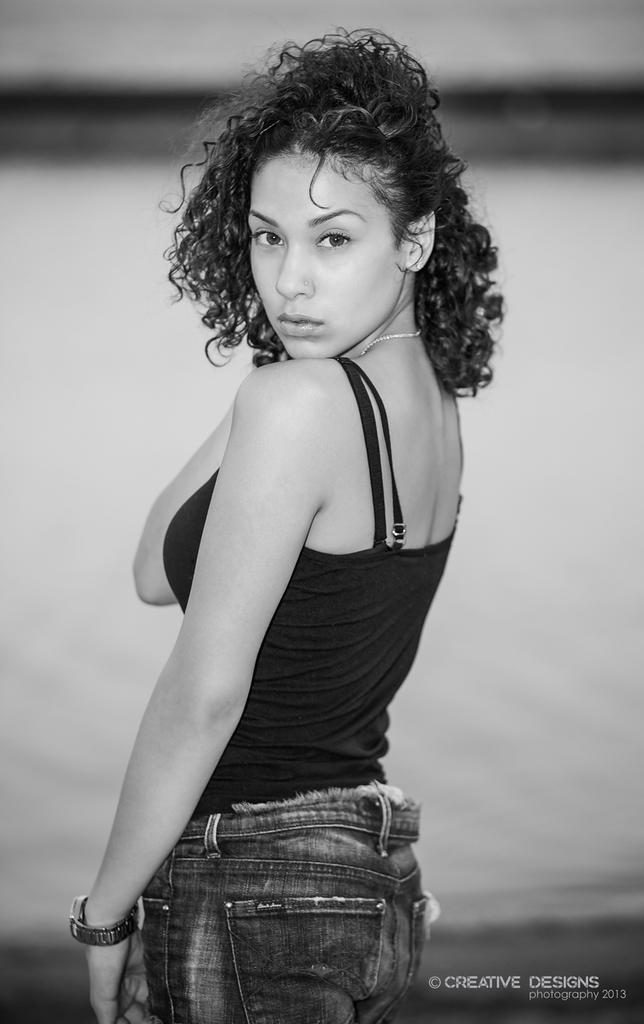Who is the main subject in the picture? There is a woman in the picture. What is the woman wearing on her wrist? The woman is wearing a watch. What is the woman's posture in the image? The woman is standing. Can you describe the background of the image? The background of the image is blurry. What type of silk fabric is draped over the dock in the image? There is no silk fabric or dock present in the image. How many lines can be seen connecting the woman to the background? There are no lines connecting the woman to the background in the image. 